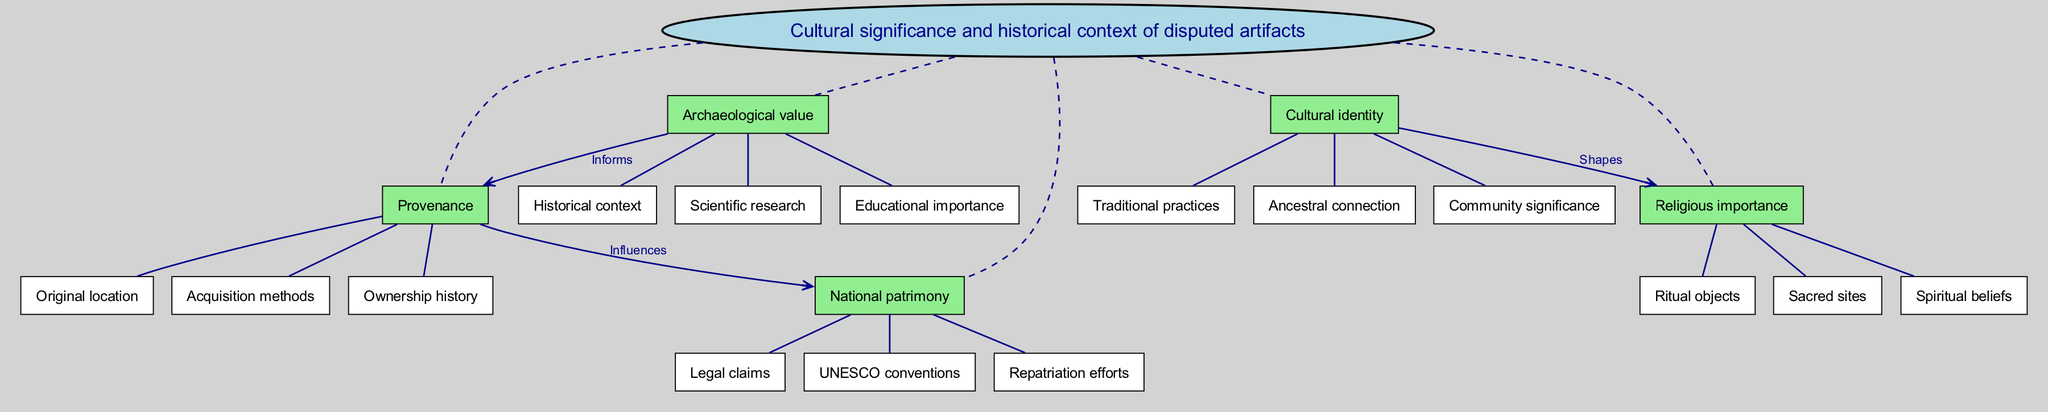What are the five main nodes in the diagram? The diagram lists five main nodes which are Provenance, Cultural identity, Religious importance, Archaeological value, and National patrimony.
Answer: Provenance, Cultural identity, Religious importance, Archaeological value, National patrimony Which sub-node is associated with Cultural identity? The sub-nodes under Cultural identity are Traditional practices, Ancestral connection, and Community significance. Any one of these can be considered as an answer, for instance, Traditional practices.
Answer: Traditional practices How many connections are in the diagram? There are three connections indicated in the diagram, showing relationships between various nodes.
Answer: 3 What influences National patrimony according to the diagram? The diagram specifies that Provenance influences National patrimony, indicating how the origin and history of artifacts impact their ownership status.
Answer: Provenance Which two main nodes have a shaping relationship according to the diagram? The relationship labeled "Shapes" indicates that Cultural identity shapes Religious importance, illustrating how one aspect influences the other in cultural contexts.
Answer: Cultural identity and Religious importance What does Archaeological value inform? According to the diagram, the Archaeological value informs Provenance. This highlights the role that archaeological findings and insights play in understanding the history of artifacts.
Answer: Provenance How many sub-nodes are under Provenance? There are three sub-nodes listed under Provenance which are Original location, Acquisition methods, and Ownership history.
Answer: 3 What kind of objects are described under Religious importance? The sub-nodes under Religious importance include Ritual objects, Sacred sites, and Spiritual beliefs, all pertaining to the spiritual and religious significance of cultural artifacts.
Answer: Ritual objects Which main node is connected to National patrimony through an influence label? The main node connected to National patrimony through the label "Influences" is Provenance, showcasing the significance of an artifact's origin in national cultural claims.
Answer: Provenance 